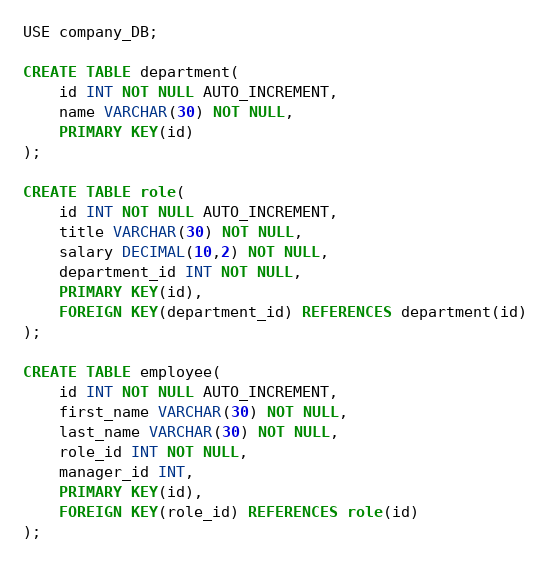Convert code to text. <code><loc_0><loc_0><loc_500><loc_500><_SQL_>USE company_DB;

CREATE TABLE department(
    id INT NOT NULL AUTO_INCREMENT,
    name VARCHAR(30) NOT NULL,
    PRIMARY KEY(id)
);

CREATE TABLE role(
    id INT NOT NULL AUTO_INCREMENT,
    title VARCHAR(30) NOT NULL,
    salary DECIMAL(10,2) NOT NULL,
    department_id INT NOT NULL,
    PRIMARY KEY(id),
    FOREIGN KEY(department_id) REFERENCES department(id)
);

CREATE TABLE employee(
    id INT NOT NULL AUTO_INCREMENT,
    first_name VARCHAR(30) NOT NULL,
    last_name VARCHAR(30) NOT NULL,
    role_id INT NOT NULL,
    manager_id INT, 
    PRIMARY KEY(id),
    FOREIGN KEY(role_id) REFERENCES role(id)
);</code> 